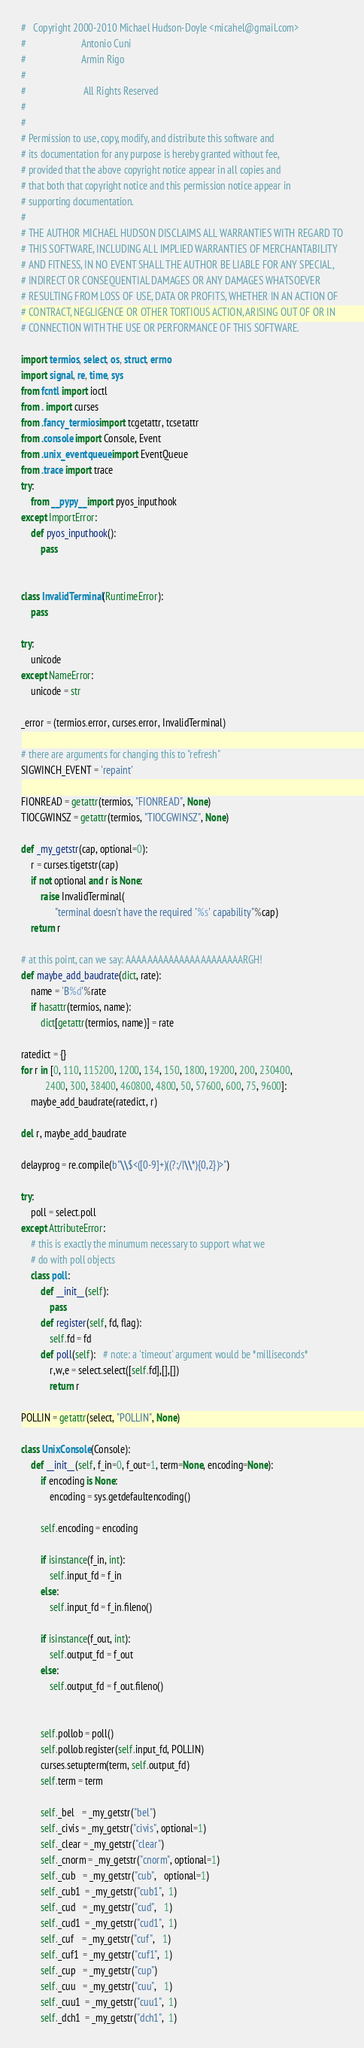Convert code to text. <code><loc_0><loc_0><loc_500><loc_500><_Python_>#   Copyright 2000-2010 Michael Hudson-Doyle <micahel@gmail.com>
#                       Antonio Cuni
#                       Armin Rigo
#
#                        All Rights Reserved
#
#
# Permission to use, copy, modify, and distribute this software and
# its documentation for any purpose is hereby granted without fee,
# provided that the above copyright notice appear in all copies and
# that both that copyright notice and this permission notice appear in
# supporting documentation.
#
# THE AUTHOR MICHAEL HUDSON DISCLAIMS ALL WARRANTIES WITH REGARD TO
# THIS SOFTWARE, INCLUDING ALL IMPLIED WARRANTIES OF MERCHANTABILITY
# AND FITNESS, IN NO EVENT SHALL THE AUTHOR BE LIABLE FOR ANY SPECIAL,
# INDIRECT OR CONSEQUENTIAL DAMAGES OR ANY DAMAGES WHATSOEVER
# RESULTING FROM LOSS OF USE, DATA OR PROFITS, WHETHER IN AN ACTION OF
# CONTRACT, NEGLIGENCE OR OTHER TORTIOUS ACTION, ARISING OUT OF OR IN
# CONNECTION WITH THE USE OR PERFORMANCE OF THIS SOFTWARE.

import termios, select, os, struct, errno
import signal, re, time, sys
from fcntl import ioctl
from . import curses
from .fancy_termios import tcgetattr, tcsetattr
from .console import Console, Event
from .unix_eventqueue import EventQueue
from .trace import trace
try:
    from __pypy__ import pyos_inputhook
except ImportError:
    def pyos_inputhook():
        pass


class InvalidTerminal(RuntimeError):
    pass

try:
    unicode
except NameError:
    unicode = str

_error = (termios.error, curses.error, InvalidTerminal)

# there are arguments for changing this to "refresh"
SIGWINCH_EVENT = 'repaint'

FIONREAD = getattr(termios, "FIONREAD", None)
TIOCGWINSZ = getattr(termios, "TIOCGWINSZ", None)

def _my_getstr(cap, optional=0):
    r = curses.tigetstr(cap)
    if not optional and r is None:
        raise InvalidTerminal(
              "terminal doesn't have the required '%s' capability"%cap)
    return r

# at this point, can we say: AAAAAAAAAAAAAAAAAAAAAARGH!
def maybe_add_baudrate(dict, rate):
    name = 'B%d'%rate
    if hasattr(termios, name):
        dict[getattr(termios, name)] = rate

ratedict = {}
for r in [0, 110, 115200, 1200, 134, 150, 1800, 19200, 200, 230400,
          2400, 300, 38400, 460800, 4800, 50, 57600, 600, 75, 9600]:
    maybe_add_baudrate(ratedict, r)

del r, maybe_add_baudrate

delayprog = re.compile(b"\\$<([0-9]+)((?:/|\\*){0,2})>")

try:
    poll = select.poll
except AttributeError:
    # this is exactly the minumum necessary to support what we
    # do with poll objects
    class poll:
        def __init__(self):
            pass
        def register(self, fd, flag):
            self.fd = fd
        def poll(self):   # note: a 'timeout' argument would be *milliseconds*
            r,w,e = select.select([self.fd],[],[])
            return r

POLLIN = getattr(select, "POLLIN", None)

class UnixConsole(Console):
    def __init__(self, f_in=0, f_out=1, term=None, encoding=None):
        if encoding is None:
            encoding = sys.getdefaultencoding()
            
        self.encoding = encoding

        if isinstance(f_in, int):
            self.input_fd = f_in
        else:
            self.input_fd = f_in.fileno()

        if isinstance(f_out, int):
            self.output_fd = f_out
        else:
            self.output_fd = f_out.fileno()
        

        self.pollob = poll()
        self.pollob.register(self.input_fd, POLLIN)
        curses.setupterm(term, self.output_fd)
        self.term = term
        
        self._bel   = _my_getstr("bel")
        self._civis = _my_getstr("civis", optional=1)
        self._clear = _my_getstr("clear")
        self._cnorm = _my_getstr("cnorm", optional=1)
        self._cub   = _my_getstr("cub",   optional=1)
        self._cub1  = _my_getstr("cub1",  1)
        self._cud   = _my_getstr("cud",   1)
        self._cud1  = _my_getstr("cud1",  1)
        self._cuf   = _my_getstr("cuf",   1)
        self._cuf1  = _my_getstr("cuf1",  1)
        self._cup   = _my_getstr("cup")
        self._cuu   = _my_getstr("cuu",   1)
        self._cuu1  = _my_getstr("cuu1",  1)
        self._dch1  = _my_getstr("dch1",  1)</code> 